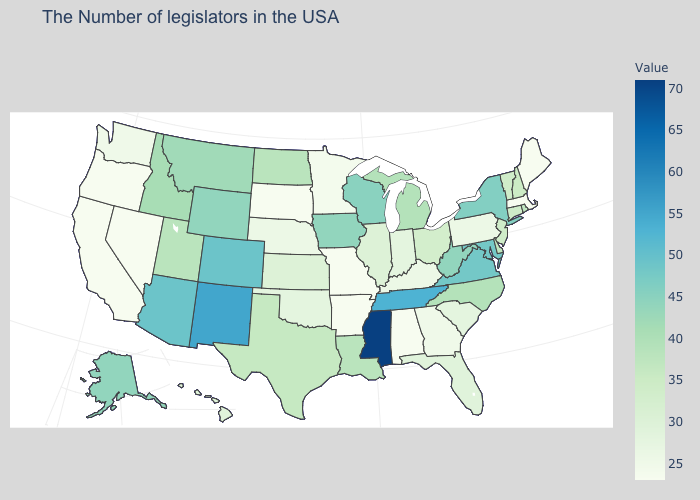Which states have the lowest value in the USA?
Short answer required. Maine, Massachusetts, Alabama, Missouri, Arkansas, South Dakota, Nevada, California, Oregon. Which states have the lowest value in the Northeast?
Write a very short answer. Maine, Massachusetts. Among the states that border New Mexico , which have the highest value?
Answer briefly. Colorado, Arizona. Among the states that border Ohio , does Kentucky have the lowest value?
Give a very brief answer. Yes. Which states have the lowest value in the USA?
Be succinct. Maine, Massachusetts, Alabama, Missouri, Arkansas, South Dakota, Nevada, California, Oregon. 